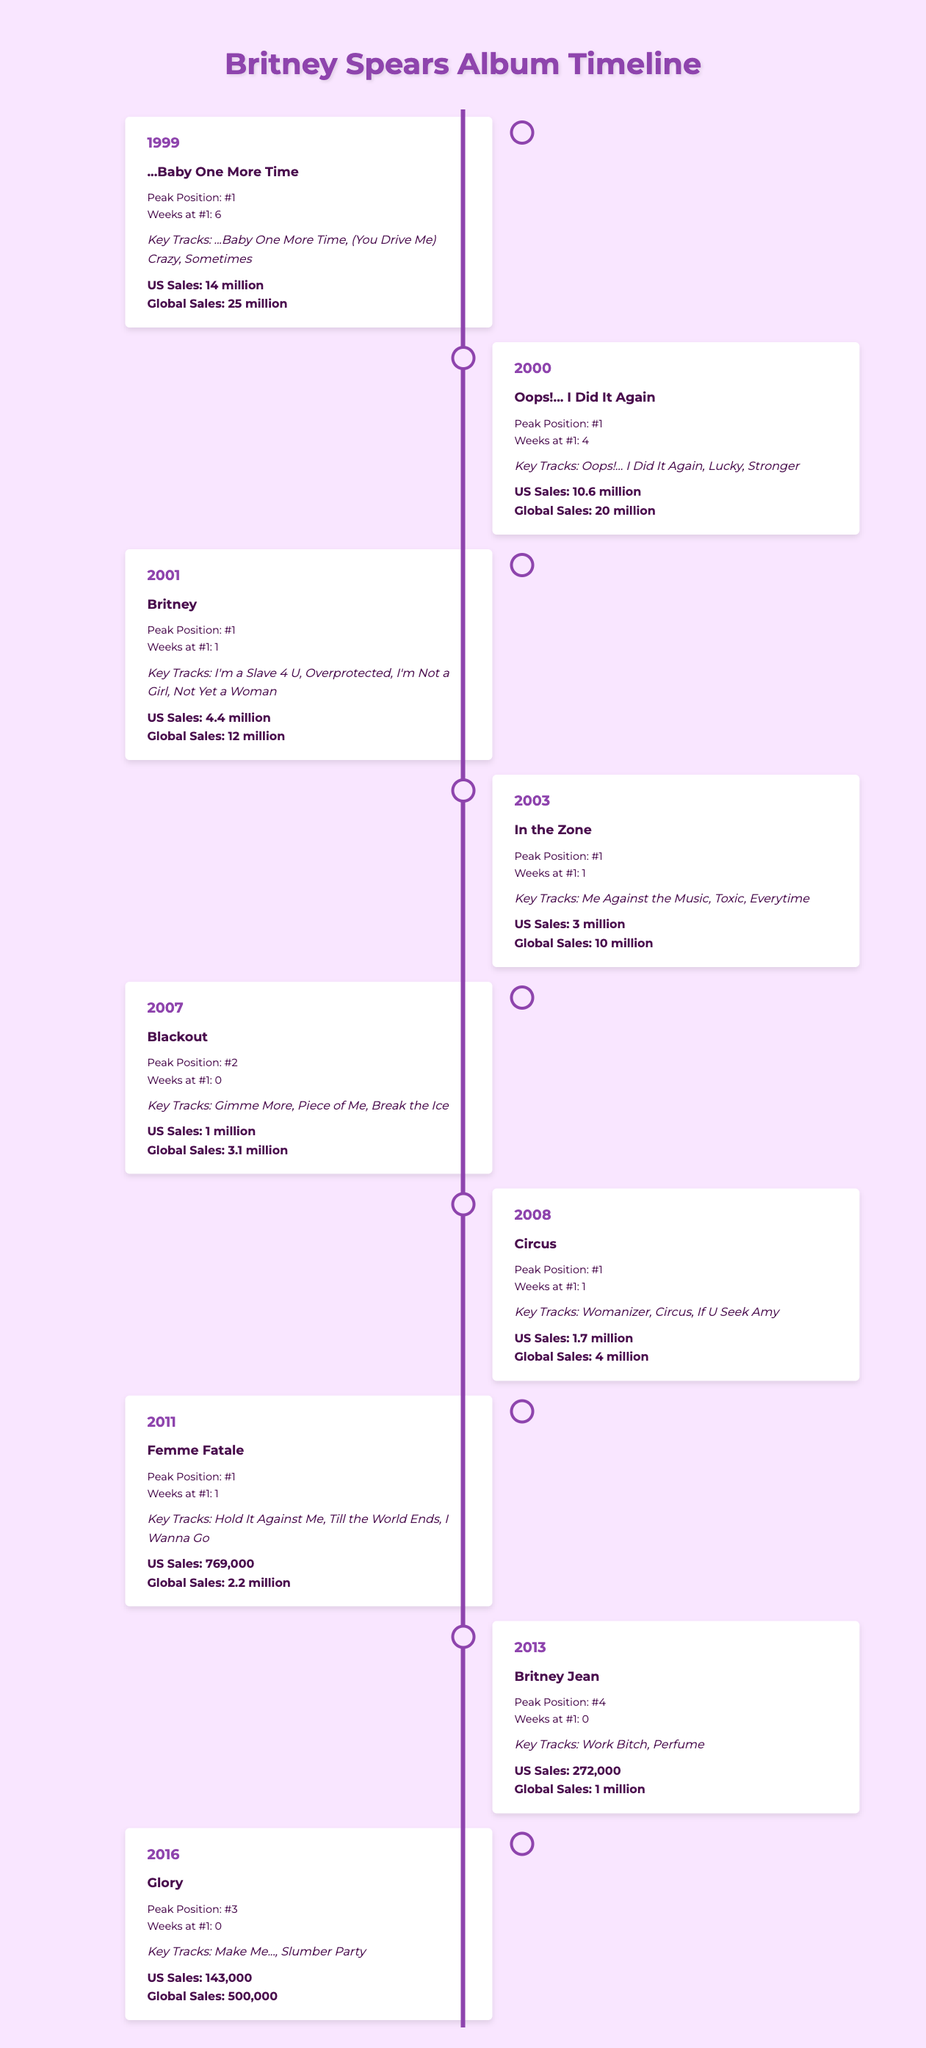What year was Britney's debut album released? The debut album, "...Baby One More Time," was released in 1999. This is directly stated in the timeline.
Answer: 1999 Which album had the highest global sales? "...Baby One More Time" had global sales of 25 million, which is higher than any other album listed in the timeline.
Answer: ...Baby One More Time How many weeks did "Oops!... I Did It Again" stay at number one? According to the table, "Oops!... I Did It Again" peaked at position 1 and stayed there for 4 weeks.
Answer: 4 weeks What is the total US sales for the albums released from 2007 to 2016? The US sales from 2007 to 2016 are as follows: "Blackout" (1 million), "Circus" (1.7 million), "Femme Fatale" (769,000), "Britney Jean" (272,000), and "Glory" (143,000). Adding these gives 1 + 1.7 + 0.769 + 0.272 + 0.143 = 3.884 million.
Answer: 3.884 million Did any album released after 2006 peak at number one? The albums released after 2006 are "Circus," "Femme Fatale," "Britney Jean," and "Glory." Only "Circus" and "Femme Fatale" peaked at number one, as indicated in the data, while the others did not.
Answer: Yes Which album had the least US sales and what were those sales? "Glory," released in 2016, had the least US sales of 143,000. This is the lowest figure when comparing all the albums listed in the table.
Answer: 143,000 How many albums peaked at number one in the first four years of Britney's career (1999-2003)? The albums that peaked at number one from 1999 to 2003 are "...Baby One More Time," "Oops!... I Did It Again," "Britney," and "In the Zone," giving a total of four albums.
Answer: 4 albums Which album had a peak position of number four? "Britney Jean," released in 2013, is the only album that peaked at position four, as indicated in the data.
Answer: Britney Jean What percentage of total global sales does "Femme Fatale" represent from all albums listed? The global sales for all albums combined (25 + 20 + 12 + 10 + 3.1 + 4 + 2.2 + 1 + 0.5) amount to 73.8 million. "Femme Fatale" had global sales of 2.2 million. The percentage is (2.2/73.8) * 100 = approximately 2.98%.
Answer: Approximately 2.98% 